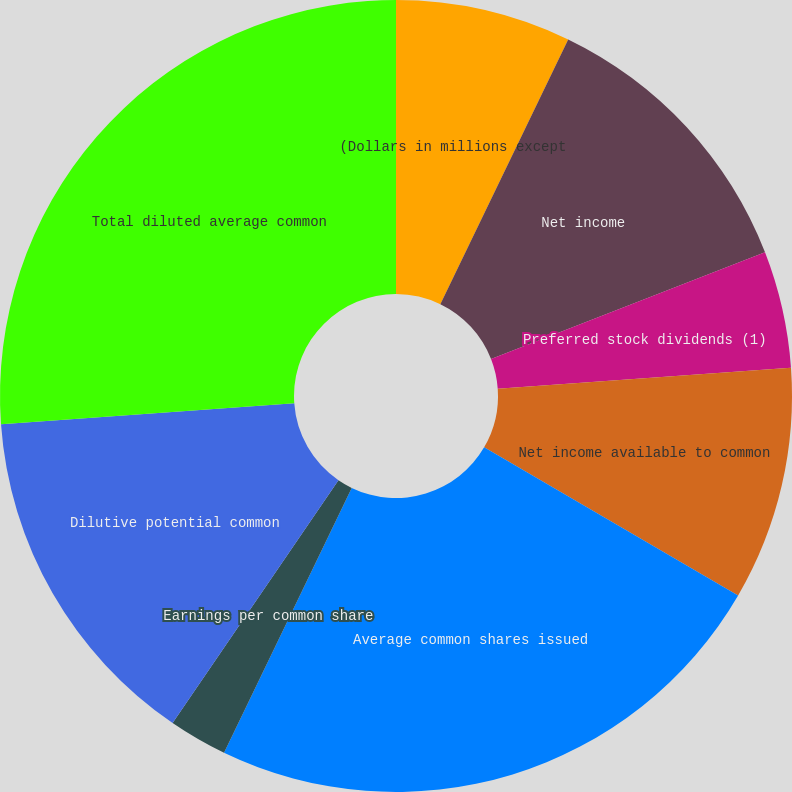Convert chart. <chart><loc_0><loc_0><loc_500><loc_500><pie_chart><fcel>(Dollars in millions except<fcel>Net income<fcel>Preferred stock dividends (1)<fcel>Net income available to common<fcel>Average common shares issued<fcel>Earnings per common share<fcel>Dilutive potential common<fcel>Total diluted average common<fcel>Diluted earnings per common<nl><fcel>7.16%<fcel>11.93%<fcel>4.77%<fcel>9.54%<fcel>23.75%<fcel>2.39%<fcel>14.32%<fcel>26.14%<fcel>0.0%<nl></chart> 